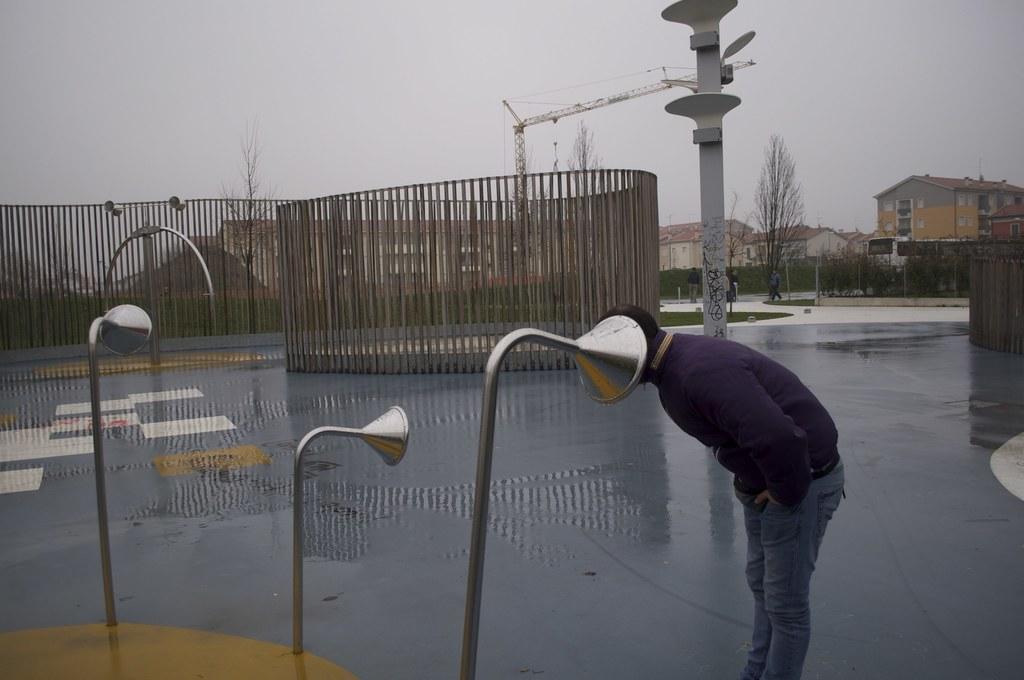Please provide a concise description of this image. In this image we can see a person standing on the road, grills, construction crane, tower, buildings, trees, barrier poles and sky. 